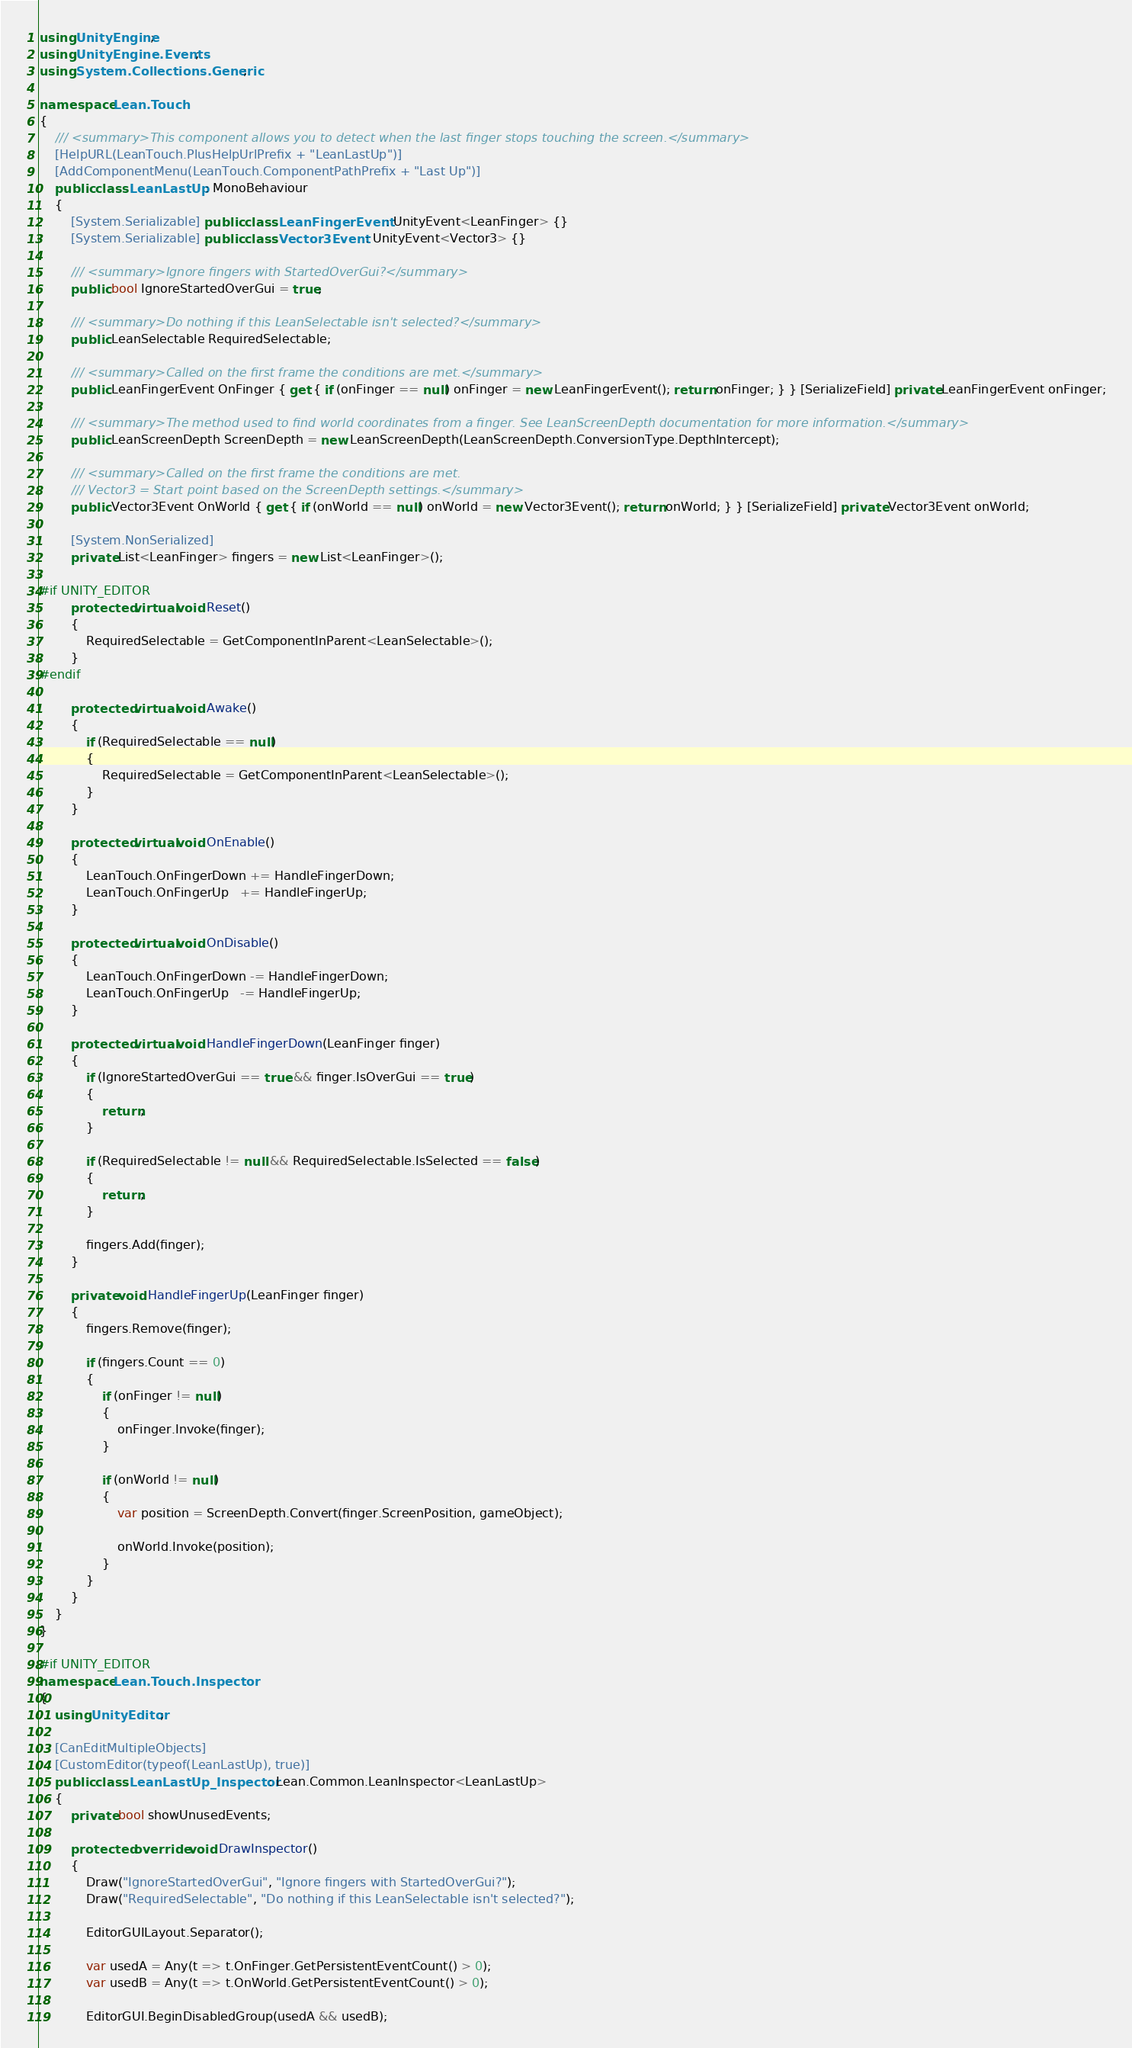<code> <loc_0><loc_0><loc_500><loc_500><_C#_>using UnityEngine;
using UnityEngine.Events;
using System.Collections.Generic;

namespace Lean.Touch
{
	/// <summary>This component allows you to detect when the last finger stops touching the screen.</summary>
	[HelpURL(LeanTouch.PlusHelpUrlPrefix + "LeanLastUp")]
	[AddComponentMenu(LeanTouch.ComponentPathPrefix + "Last Up")]
	public class LeanLastUp : MonoBehaviour
	{
		[System.Serializable] public class LeanFingerEvent : UnityEvent<LeanFinger> {}
		[System.Serializable] public class Vector3Event : UnityEvent<Vector3> {}

		/// <summary>Ignore fingers with StartedOverGui?</summary>
		public bool IgnoreStartedOverGui = true;

		/// <summary>Do nothing if this LeanSelectable isn't selected?</summary>
		public LeanSelectable RequiredSelectable;

		/// <summary>Called on the first frame the conditions are met.</summary>
		public LeanFingerEvent OnFinger { get { if (onFinger == null) onFinger = new LeanFingerEvent(); return onFinger; } } [SerializeField] private LeanFingerEvent onFinger;

		/// <summary>The method used to find world coordinates from a finger. See LeanScreenDepth documentation for more information.</summary>
		public LeanScreenDepth ScreenDepth = new LeanScreenDepth(LeanScreenDepth.ConversionType.DepthIntercept);

		/// <summary>Called on the first frame the conditions are met.
		/// Vector3 = Start point based on the ScreenDepth settings.</summary>
		public Vector3Event OnWorld { get { if (onWorld == null) onWorld = new Vector3Event(); return onWorld; } } [SerializeField] private Vector3Event onWorld;

		[System.NonSerialized]
		private List<LeanFinger> fingers = new List<LeanFinger>();

#if UNITY_EDITOR
		protected virtual void Reset()
		{
			RequiredSelectable = GetComponentInParent<LeanSelectable>();
		}
#endif

		protected virtual void Awake()
		{
			if (RequiredSelectable == null)
			{
				RequiredSelectable = GetComponentInParent<LeanSelectable>();
			}
		}

		protected virtual void OnEnable()
		{
			LeanTouch.OnFingerDown += HandleFingerDown;
			LeanTouch.OnFingerUp   += HandleFingerUp;
		}

		protected virtual void OnDisable()
		{
			LeanTouch.OnFingerDown -= HandleFingerDown;
			LeanTouch.OnFingerUp   -= HandleFingerUp;
		}

		protected virtual void HandleFingerDown(LeanFinger finger)
		{
			if (IgnoreStartedOverGui == true && finger.IsOverGui == true)
			{
				return;
			}

			if (RequiredSelectable != null && RequiredSelectable.IsSelected == false)
			{
				return;
			}

			fingers.Add(finger);
		}

		private void HandleFingerUp(LeanFinger finger)
		{
			fingers.Remove(finger);

			if (fingers.Count == 0)
			{
				if (onFinger != null)
				{
					onFinger.Invoke(finger);
				}

				if (onWorld != null)
				{
					var position = ScreenDepth.Convert(finger.ScreenPosition, gameObject);

					onWorld.Invoke(position);
				}
			}
		}
	}
}

#if UNITY_EDITOR
namespace Lean.Touch.Inspector
{
	using UnityEditor;

	[CanEditMultipleObjects]
	[CustomEditor(typeof(LeanLastUp), true)]
	public class LeanLastUp_Inspector : Lean.Common.LeanInspector<LeanLastUp>
	{
		private bool showUnusedEvents;

		protected override void DrawInspector()
		{
			Draw("IgnoreStartedOverGui", "Ignore fingers with StartedOverGui?");
			Draw("RequiredSelectable", "Do nothing if this LeanSelectable isn't selected?");

			EditorGUILayout.Separator();

			var usedA = Any(t => t.OnFinger.GetPersistentEventCount() > 0);
			var usedB = Any(t => t.OnWorld.GetPersistentEventCount() > 0);

			EditorGUI.BeginDisabledGroup(usedA && usedB);</code> 